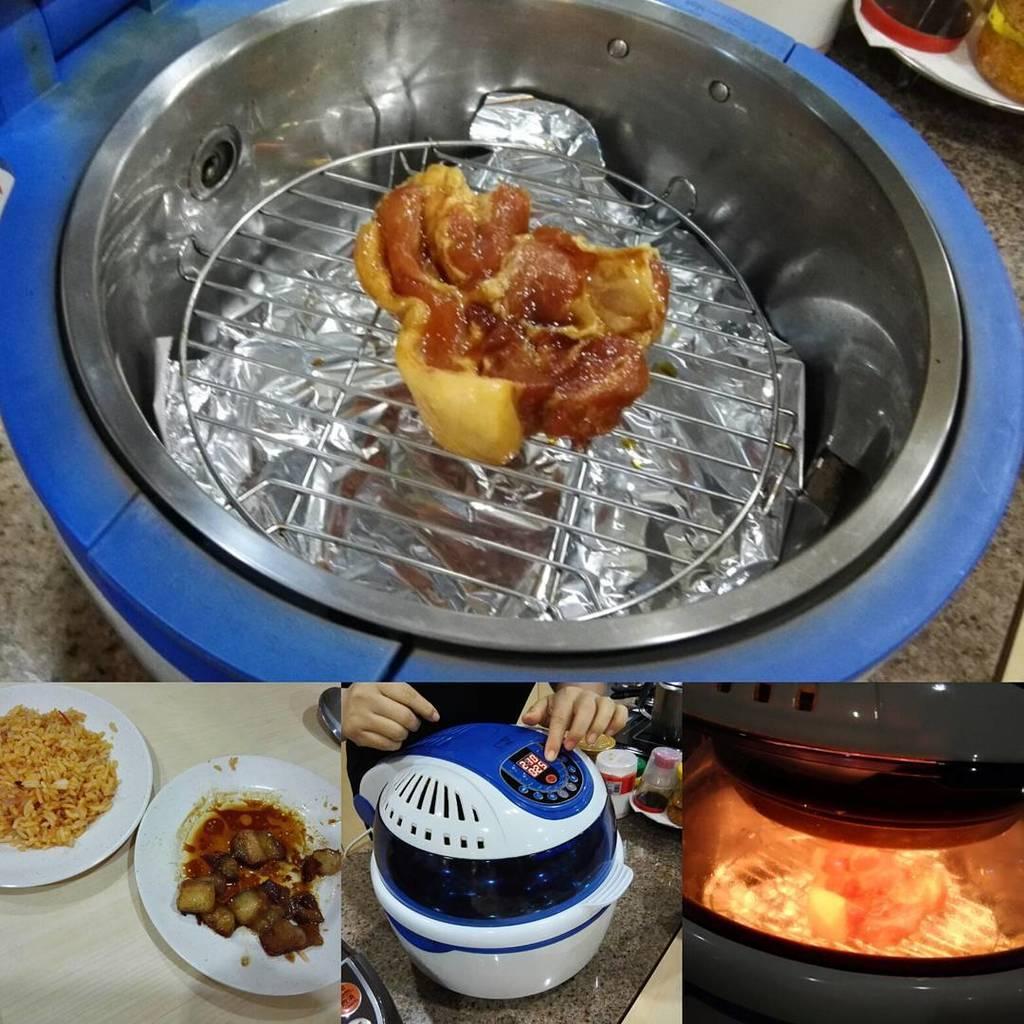Please provide a concise description of this image. At the bottom, I can see plates in which food items are there, vessels and an electric micro oven on a table. At the top, I can see a vessel, stand, food items and bottles. This image is taken may be in a room. 